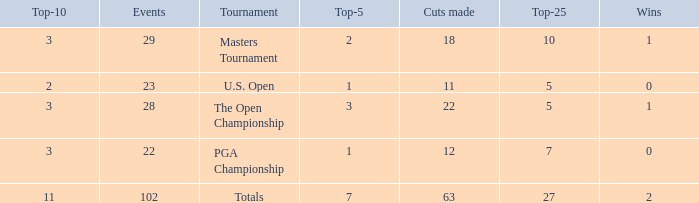How many top 10s associated with 3 top 5s and under 22 cuts made? None. 